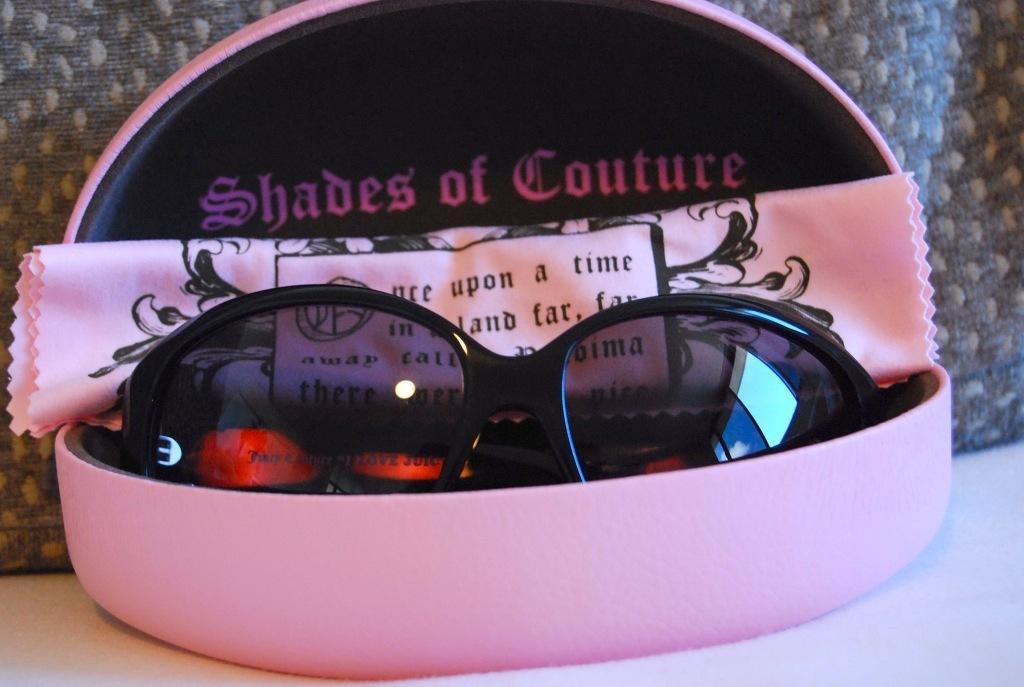Describe this image in one or two sentences. In this image inside a pink box there is a pair of sunglasses. This is a cloth. In the background there is cloth. 